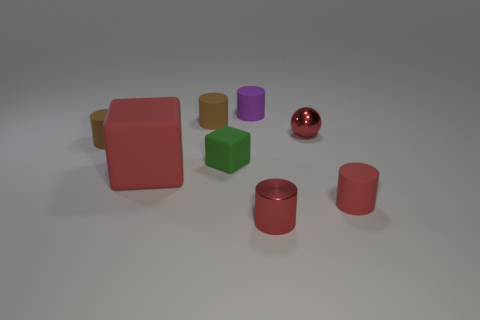Subtract all red rubber cylinders. How many cylinders are left? 4 Subtract all purple cylinders. How many cylinders are left? 4 Subtract all gray cylinders. Subtract all brown balls. How many cylinders are left? 5 Add 2 matte things. How many objects exist? 10 Subtract all balls. How many objects are left? 7 Add 2 small shiny objects. How many small shiny objects are left? 4 Add 1 yellow matte spheres. How many yellow matte spheres exist? 1 Subtract 1 red cylinders. How many objects are left? 7 Subtract all big yellow blocks. Subtract all large rubber things. How many objects are left? 7 